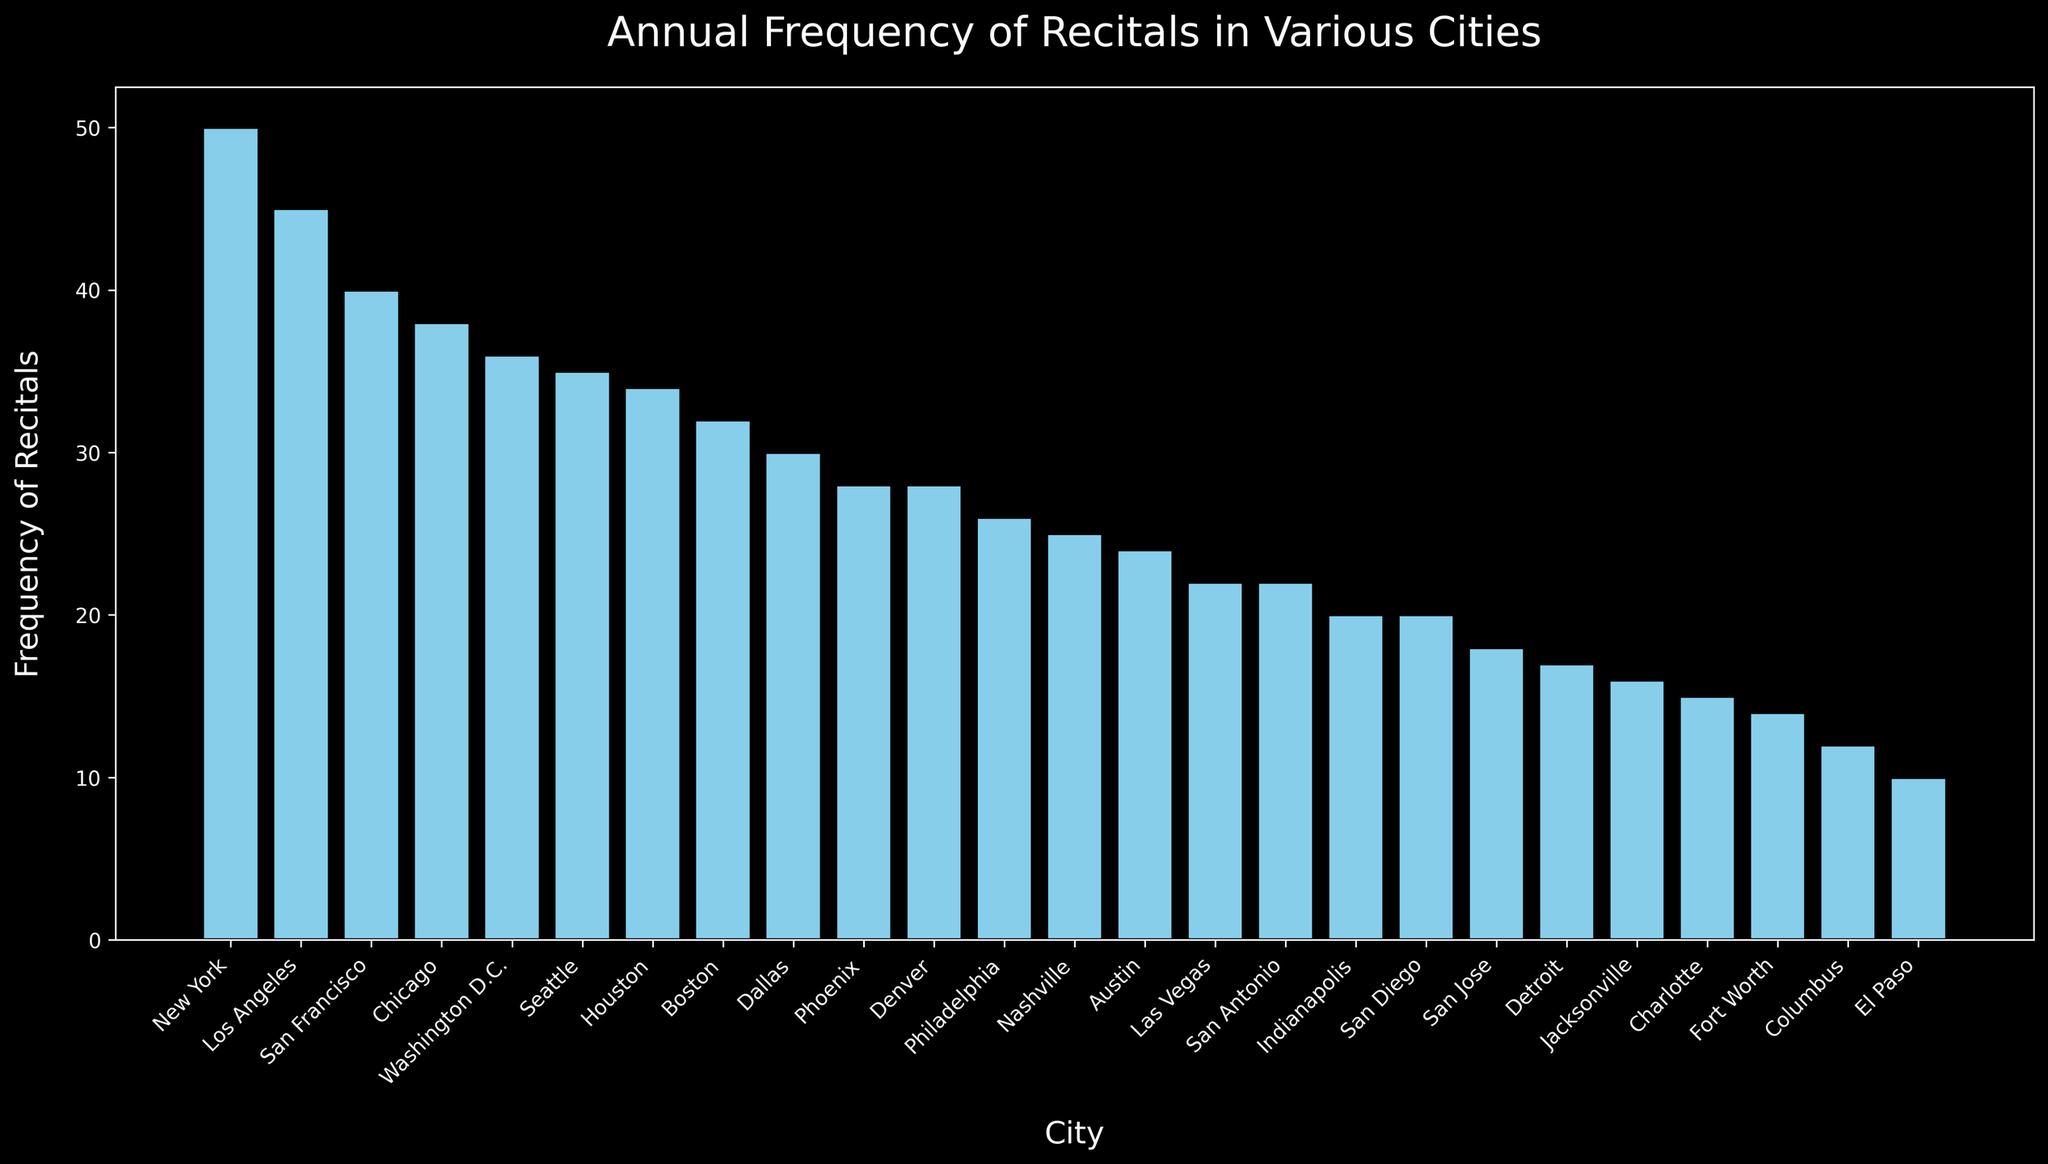Which city holds the most recitals annually? Look at the bar representing recitals in each city. The tallest bar corresponds to New York.
Answer: New York Which city holds fewer recitals annually: Dallas or Austin? Compare the heights of the bars for Dallas and Austin. The bar for Austin is shorter than the one for Dallas.
Answer: Austin What is the total number of recitals held annually in New York, Los Angeles, and Chicago combined? Add the frequencies of recitals for New York (50), Los Angeles (45), and Chicago (38). \(50 + 45 + 38 = 133\)
Answer: 133 How many more recitals does New York hold annually compared to Philadelphia? Subtract the number of recitals in Philadelphia (26) from the number in New York (50). \(50 - 26 = 24\)
Answer: 24 What is the average number of recitals held annually in Houston, Phoenix, and San Francisco? Add the frequencies for Houston (34), Phoenix (28), and San Francisco (40), then divide by 3. \(\frac{34 + 28 + 40}{3} = \frac{102}{3} = 34\)
Answer: 34 Which city has the highest number of recitals among Seattle, Denver, and Washington D.C.? Compare the heights of the bars for Seattle, Denver, and Washington D.C. The bar for Washington D.C. is the tallest.
Answer: Washington D.C How many cities have an annual recital frequency of 20 or more? Count the number of bars with a height of 20 or more. This includes New York, Los Angeles, Chicago, Houston, Phoenix, Philadelphia, San Antonio, San Diego, Dallas, Austin, Nashville, Washington D.C., Boston, San Francisco, and Seattle.
Answer: 15 What is the median frequency of recitals held annually among the 24 cities? Arrange the frequencies in ascending order and find the middle value(s). The median is the average of the 12th and 13th values. Frequencies listed: [10, 12, 14, 15, 16, 17, 18, 20, 20, 22, 22, 24, 25, 26, 28, 28, 30, 32, 34, 35, 36, 38, 40, 45, 50]. Median is \(\frac{24 + 25}{2} = 24.5\).
Answer: 24.5 What visual attribute differentiates the bars in this chart the most? The attribute that stands out is the height of the bars, indicating the annual frequency of recitals in each city.
Answer: Height 